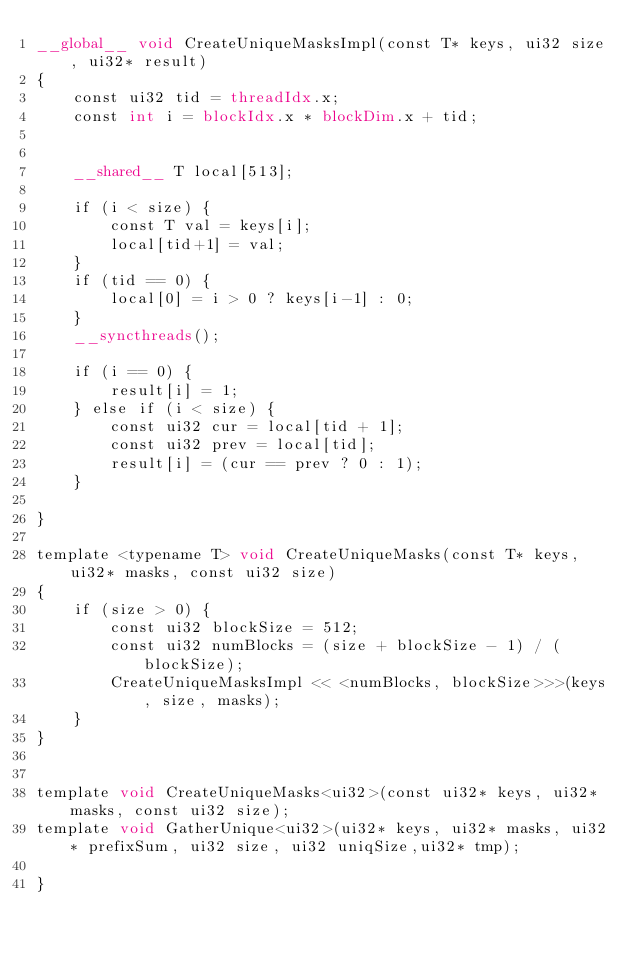Convert code to text. <code><loc_0><loc_0><loc_500><loc_500><_Cuda_>__global__ void CreateUniqueMasksImpl(const T* keys, ui32 size, ui32* result)
{
    const ui32 tid = threadIdx.x;
    const int i = blockIdx.x * blockDim.x + tid;


    __shared__ T local[513];

    if (i < size) {
        const T val = keys[i];
        local[tid+1] = val;
    }
    if (tid == 0) {
        local[0] = i > 0 ? keys[i-1] : 0;
    }
    __syncthreads();

    if (i == 0) {
        result[i] = 1;
    } else if (i < size) {
        const ui32 cur = local[tid + 1];
        const ui32 prev = local[tid];
        result[i] = (cur == prev ? 0 : 1);
    }

}

template <typename T> void CreateUniqueMasks(const T* keys, ui32* masks, const ui32 size)
{
    if (size > 0) {
        const ui32 blockSize = 512;
        const ui32 numBlocks = (size + blockSize - 1) / (blockSize);
        CreateUniqueMasksImpl << <numBlocks, blockSize>>>(keys, size, masks);
    }
}


template void CreateUniqueMasks<ui32>(const ui32* keys, ui32* masks, const ui32 size);
template void GatherUnique<ui32>(ui32* keys, ui32* masks, ui32* prefixSum, ui32 size, ui32 uniqSize,ui32* tmp);

}
</code> 